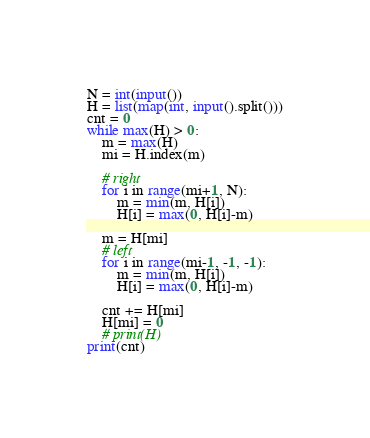<code> <loc_0><loc_0><loc_500><loc_500><_Python_>N = int(input())
H = list(map(int, input().split()))
cnt = 0
while max(H) > 0:
    m = max(H)
    mi = H.index(m)

    # right
    for i in range(mi+1, N):
        m = min(m, H[i])
        H[i] = max(0, H[i]-m)

    m = H[mi]
    # left
    for i in range(mi-1, -1, -1):
        m = min(m, H[i])
        H[i] = max(0, H[i]-m)

    cnt += H[mi]
    H[mi] = 0
    # print(H)
print(cnt)
</code> 